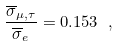Convert formula to latex. <formula><loc_0><loc_0><loc_500><loc_500>\frac { \overline { \sigma } _ { \mu , \tau } } { \overline { \sigma } _ { e } } = 0 . 1 5 3 \ ,</formula> 